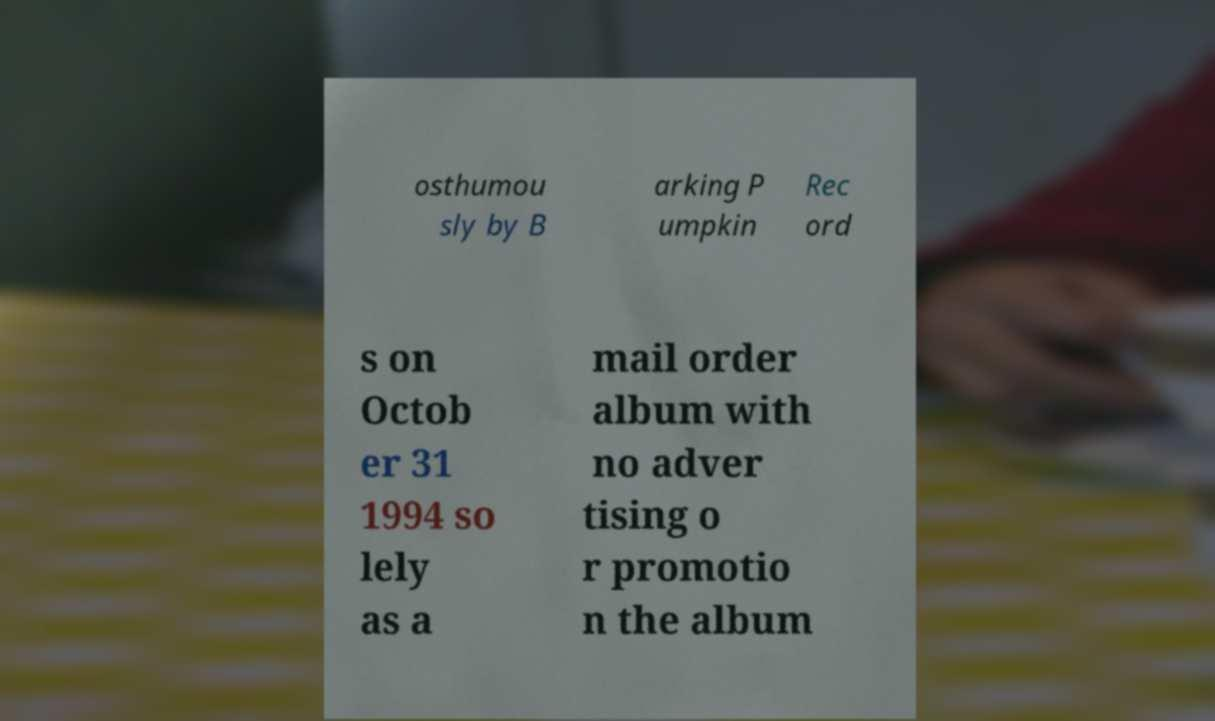I need the written content from this picture converted into text. Can you do that? osthumou sly by B arking P umpkin Rec ord s on Octob er 31 1994 so lely as a mail order album with no adver tising o r promotio n the album 